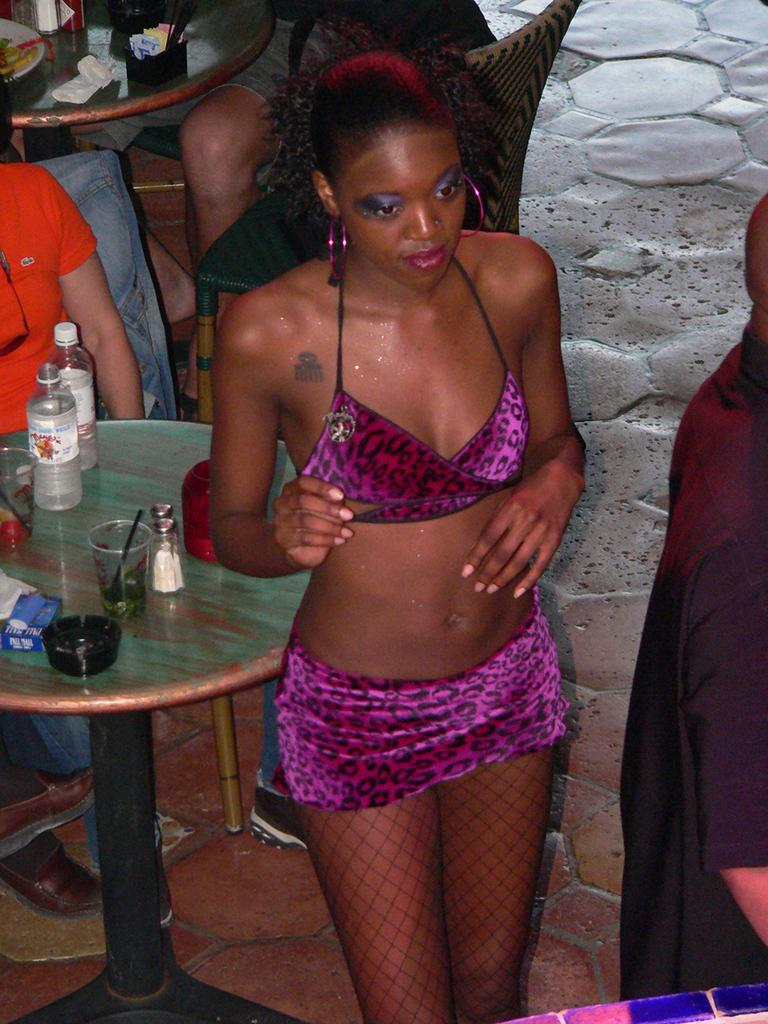What is the woman near in the image? The woman is standing near a table in the image. What items can be seen on the table? There are bottles, drinking glasses, and a bowl on the table. What are the persons in the image doing? The persons in the image are sitting on chairs. What type of ink is being used by the servant in the image? There is no servant or ink present in the image. How many bridges can be seen in the image? There are no bridges visible in the image. 